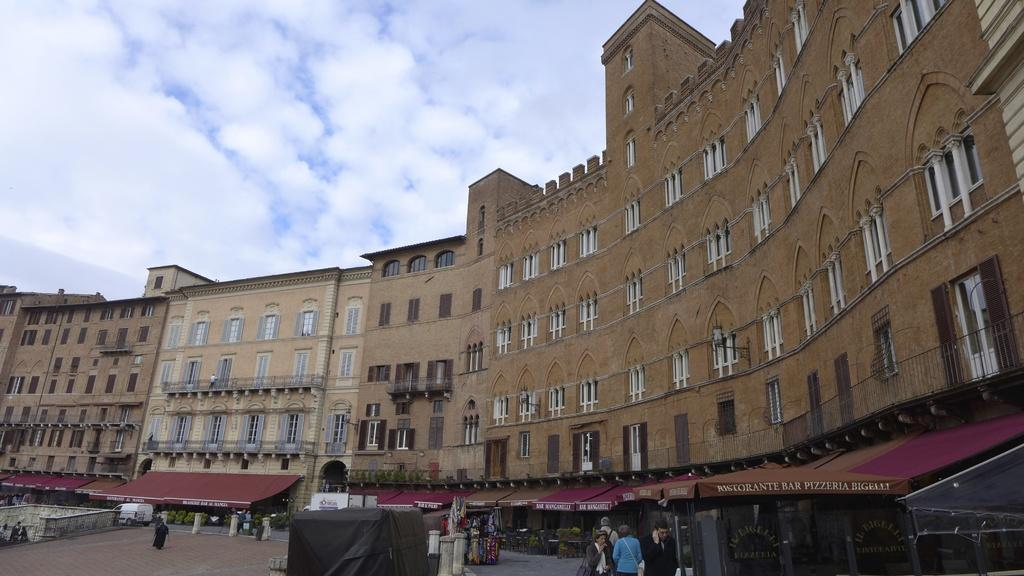What is the main focus of the image? The main focus of the image is the buildings in the center. What else can be seen in the image besides the buildings? There are stalls and people in the image. How many windows can be seen on the buildings? The buildings have many windows. Can you tell me how many flocks of birds are flying over the buildings in the image? There is no mention of birds or flocks in the image, so it is not possible to answer that question. 